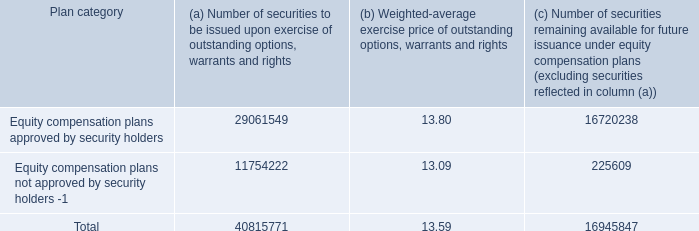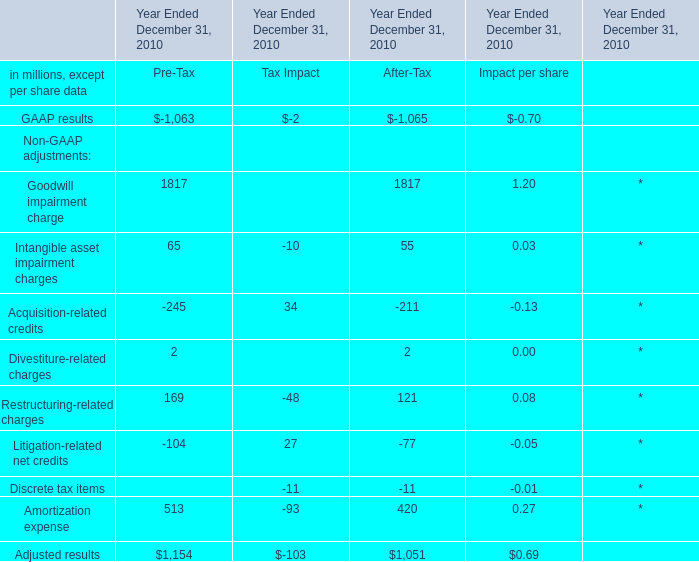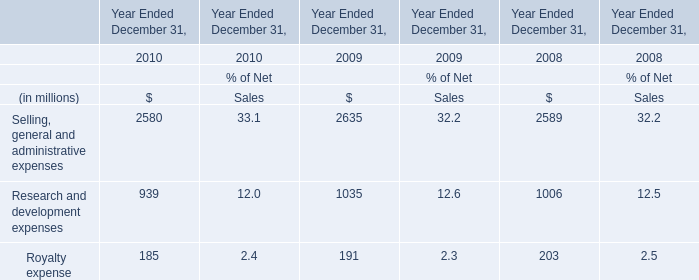what is the highest total amount of Intangible asset impairment charges? (in million) 
Answer: 65. 